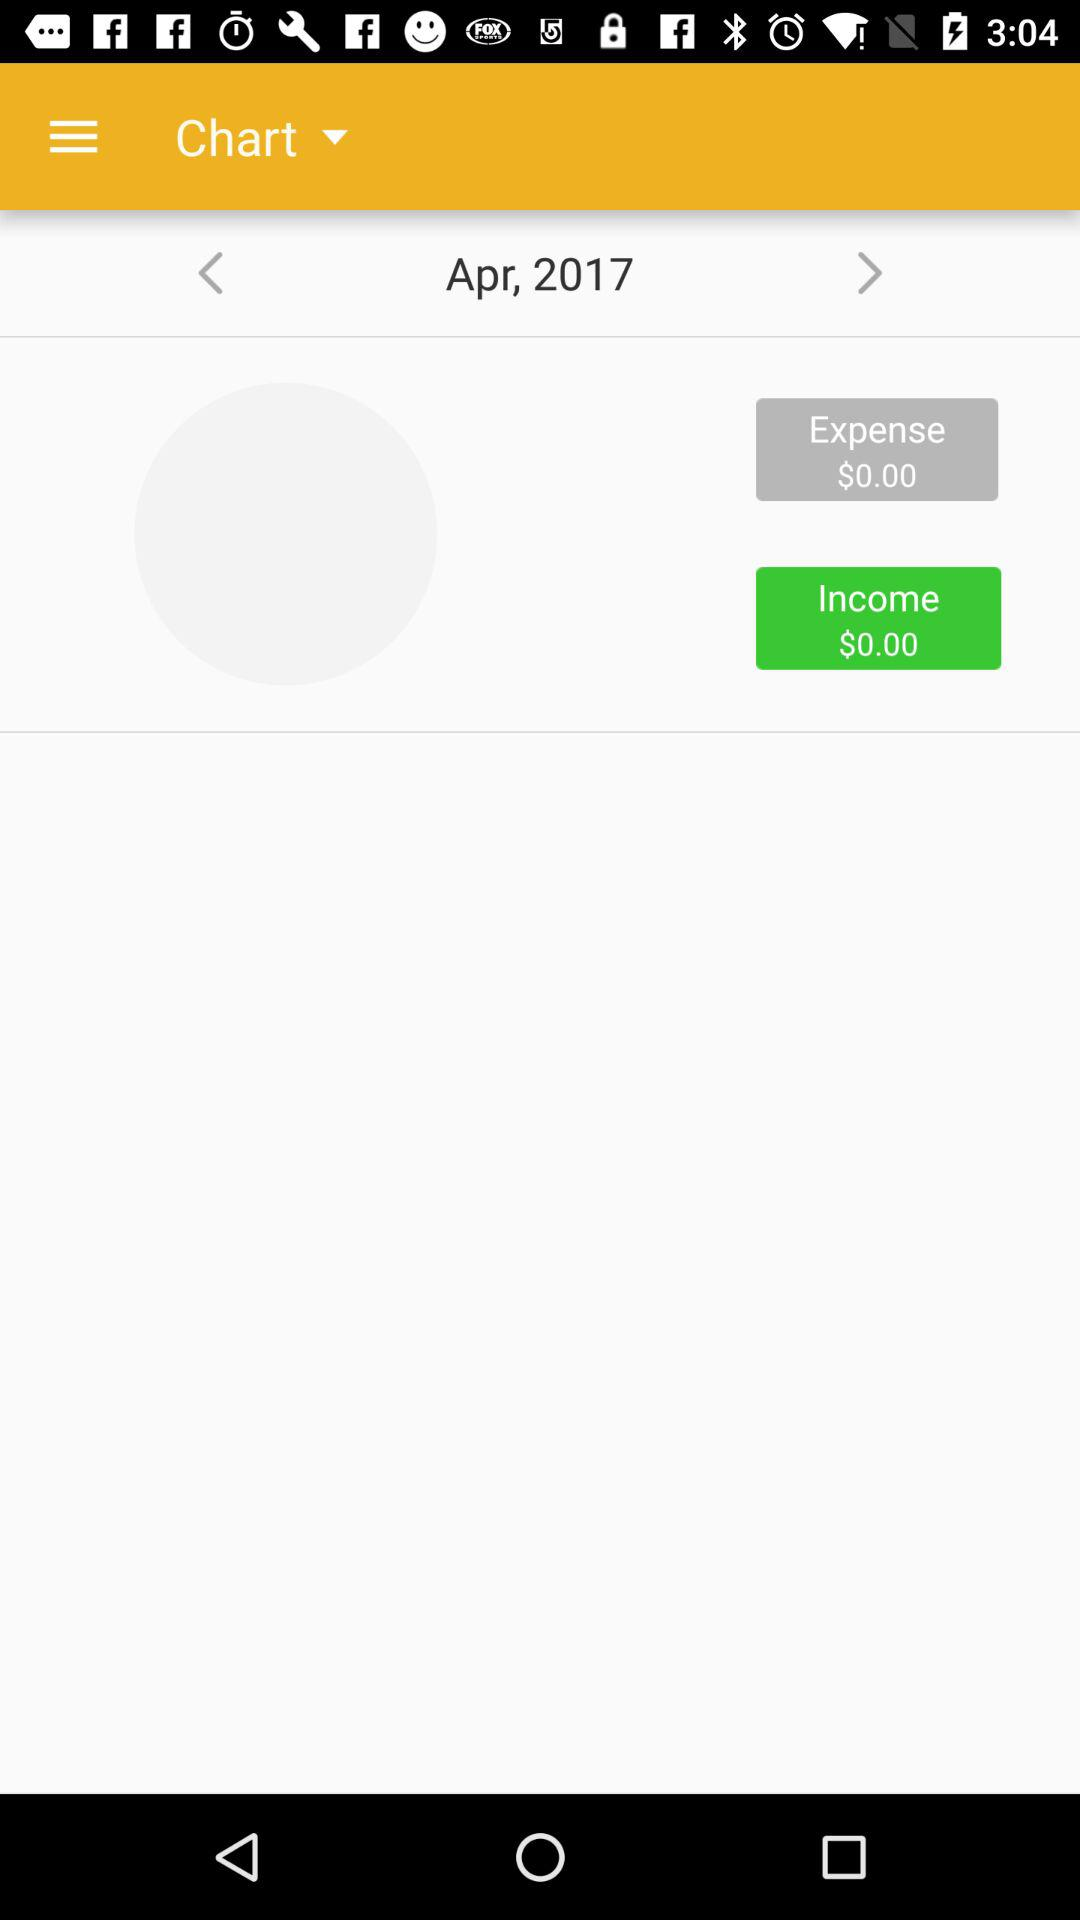What are the month and year? The month and year are April and 2017, respectively. 